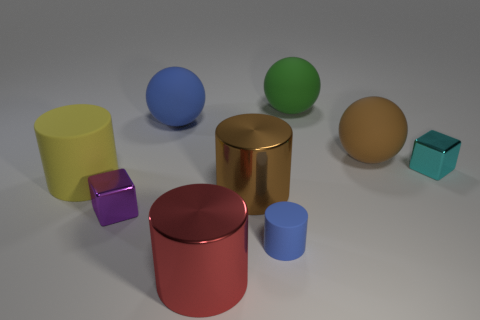Subtract all cylinders. How many objects are left? 5 Subtract all small red blocks. Subtract all large red cylinders. How many objects are left? 8 Add 9 small blue rubber cylinders. How many small blue rubber cylinders are left? 10 Add 3 shiny cylinders. How many shiny cylinders exist? 5 Subtract 1 blue cylinders. How many objects are left? 8 